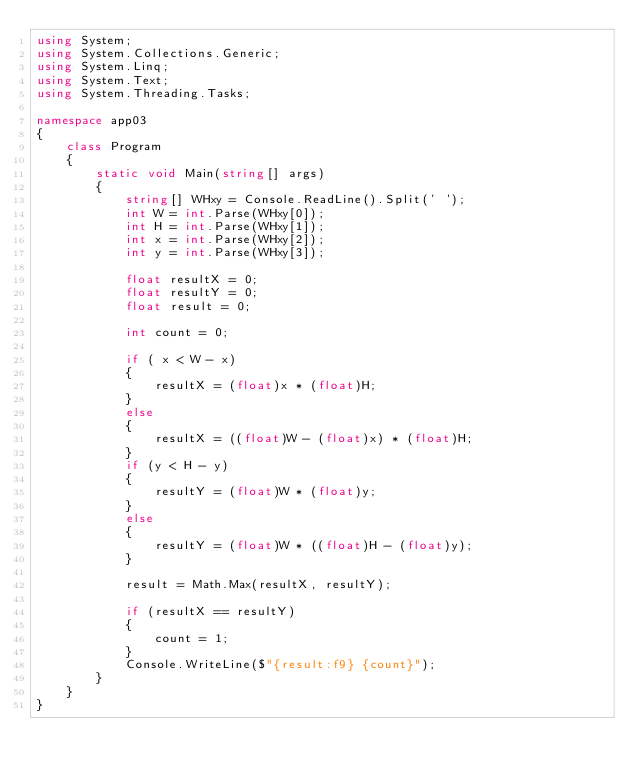<code> <loc_0><loc_0><loc_500><loc_500><_C#_>using System;
using System.Collections.Generic;
using System.Linq;
using System.Text;
using System.Threading.Tasks;

namespace app03
{
    class Program
    {
        static void Main(string[] args)
        {
            string[] WHxy = Console.ReadLine().Split(' ');
            int W = int.Parse(WHxy[0]);
            int H = int.Parse(WHxy[1]);
            int x = int.Parse(WHxy[2]);
            int y = int.Parse(WHxy[3]);

            float resultX = 0;
            float resultY = 0;
            float result = 0;

            int count = 0;

            if ( x < W - x)
            {
                resultX = (float)x * (float)H;
            }
            else
            {
                resultX = ((float)W - (float)x) * (float)H;
            }
            if (y < H - y)
            {
                resultY = (float)W * (float)y;
            }
            else
            {
                resultY = (float)W * ((float)H - (float)y);
            }

            result = Math.Max(resultX, resultY);

            if (resultX == resultY)
            {
                count = 1;
            }
            Console.WriteLine($"{result:f9} {count}");
        }
    }
}
</code> 